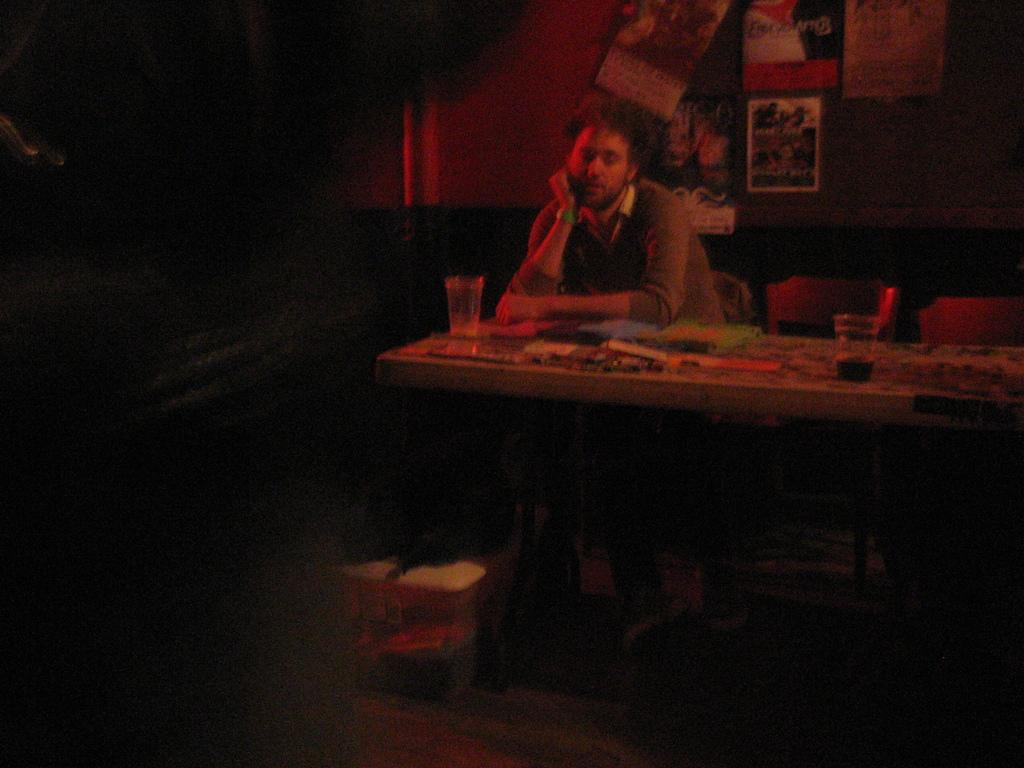What is the person in the image doing? The person is sitting on a chair. What is in front of the person? There are glasses and unspecified things in front of the person. What can be seen on the wall in the image? There are posters on the wall. What is located under the table in the image? There is a bag and a box under the table. How many rabbits can be seen in the image? There are no rabbits present in the image. Is the room in the image completely quiet? The image does not provide information about the noise level in the room, so it cannot be determined if it is quiet or not. 